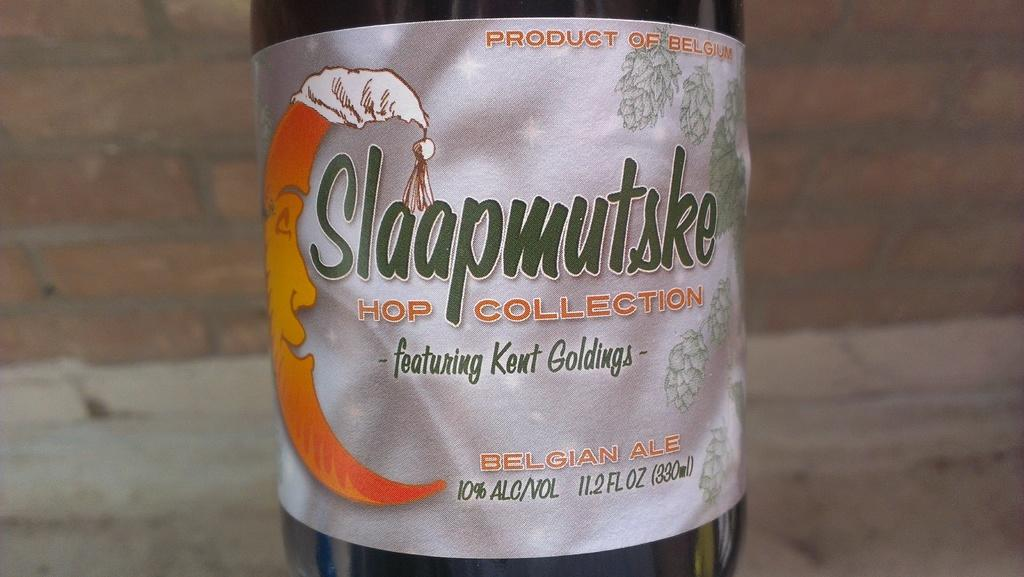<image>
Write a terse but informative summary of the picture. A bottle of a picture of a moon with on night cap on its head with the brand Slaapmutske as the brand. 